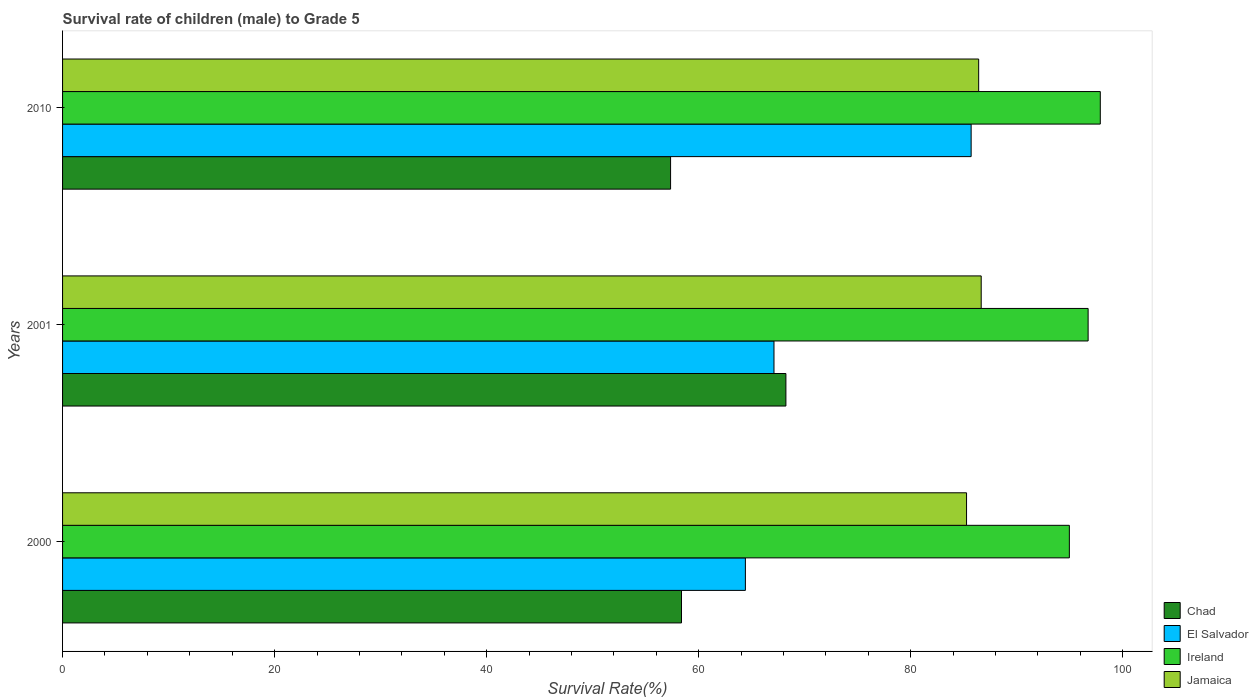How many different coloured bars are there?
Your answer should be compact. 4. How many groups of bars are there?
Offer a terse response. 3. What is the survival rate of male children to grade 5 in El Salvador in 2000?
Keep it short and to the point. 64.4. Across all years, what is the maximum survival rate of male children to grade 5 in Chad?
Your answer should be very brief. 68.22. Across all years, what is the minimum survival rate of male children to grade 5 in Chad?
Offer a very short reply. 57.35. In which year was the survival rate of male children to grade 5 in Chad minimum?
Ensure brevity in your answer.  2010. What is the total survival rate of male children to grade 5 in Jamaica in the graph?
Your response must be concise. 258.31. What is the difference between the survival rate of male children to grade 5 in Jamaica in 2001 and that in 2010?
Make the answer very short. 0.24. What is the difference between the survival rate of male children to grade 5 in Chad in 2000 and the survival rate of male children to grade 5 in Jamaica in 2001?
Offer a very short reply. -28.27. What is the average survival rate of male children to grade 5 in Jamaica per year?
Your answer should be compact. 86.1. In the year 2001, what is the difference between the survival rate of male children to grade 5 in Ireland and survival rate of male children to grade 5 in Jamaica?
Give a very brief answer. 10.08. In how many years, is the survival rate of male children to grade 5 in Ireland greater than 24 %?
Your answer should be compact. 3. What is the ratio of the survival rate of male children to grade 5 in El Salvador in 2000 to that in 2001?
Offer a very short reply. 0.96. What is the difference between the highest and the second highest survival rate of male children to grade 5 in Chad?
Give a very brief answer. 9.85. What is the difference between the highest and the lowest survival rate of male children to grade 5 in Chad?
Your answer should be very brief. 10.88. In how many years, is the survival rate of male children to grade 5 in El Salvador greater than the average survival rate of male children to grade 5 in El Salvador taken over all years?
Your answer should be compact. 1. Is it the case that in every year, the sum of the survival rate of male children to grade 5 in El Salvador and survival rate of male children to grade 5 in Ireland is greater than the sum of survival rate of male children to grade 5 in Jamaica and survival rate of male children to grade 5 in Chad?
Give a very brief answer. No. What does the 3rd bar from the top in 2010 represents?
Make the answer very short. El Salvador. What does the 1st bar from the bottom in 2010 represents?
Your answer should be very brief. Chad. Are all the bars in the graph horizontal?
Keep it short and to the point. Yes. What is the difference between two consecutive major ticks on the X-axis?
Give a very brief answer. 20. Are the values on the major ticks of X-axis written in scientific E-notation?
Your answer should be very brief. No. Does the graph contain any zero values?
Give a very brief answer. No. Does the graph contain grids?
Keep it short and to the point. No. Where does the legend appear in the graph?
Keep it short and to the point. Bottom right. How many legend labels are there?
Give a very brief answer. 4. What is the title of the graph?
Offer a terse response. Survival rate of children (male) to Grade 5. What is the label or title of the X-axis?
Make the answer very short. Survival Rate(%). What is the Survival Rate(%) in Chad in 2000?
Your response must be concise. 58.38. What is the Survival Rate(%) in El Salvador in 2000?
Provide a succinct answer. 64.4. What is the Survival Rate(%) of Ireland in 2000?
Keep it short and to the point. 94.96. What is the Survival Rate(%) in Jamaica in 2000?
Your answer should be compact. 85.26. What is the Survival Rate(%) of Chad in 2001?
Make the answer very short. 68.22. What is the Survival Rate(%) in El Salvador in 2001?
Provide a succinct answer. 67.1. What is the Survival Rate(%) in Ireland in 2001?
Provide a short and direct response. 96.73. What is the Survival Rate(%) of Jamaica in 2001?
Give a very brief answer. 86.64. What is the Survival Rate(%) in Chad in 2010?
Keep it short and to the point. 57.35. What is the Survival Rate(%) of El Salvador in 2010?
Your response must be concise. 85.7. What is the Survival Rate(%) of Ireland in 2010?
Your answer should be compact. 97.88. What is the Survival Rate(%) of Jamaica in 2010?
Give a very brief answer. 86.41. Across all years, what is the maximum Survival Rate(%) in Chad?
Ensure brevity in your answer.  68.22. Across all years, what is the maximum Survival Rate(%) of El Salvador?
Ensure brevity in your answer.  85.7. Across all years, what is the maximum Survival Rate(%) of Ireland?
Your answer should be very brief. 97.88. Across all years, what is the maximum Survival Rate(%) in Jamaica?
Provide a short and direct response. 86.64. Across all years, what is the minimum Survival Rate(%) of Chad?
Give a very brief answer. 57.35. Across all years, what is the minimum Survival Rate(%) of El Salvador?
Keep it short and to the point. 64.4. Across all years, what is the minimum Survival Rate(%) of Ireland?
Keep it short and to the point. 94.96. Across all years, what is the minimum Survival Rate(%) in Jamaica?
Offer a very short reply. 85.26. What is the total Survival Rate(%) of Chad in the graph?
Ensure brevity in your answer.  183.95. What is the total Survival Rate(%) in El Salvador in the graph?
Ensure brevity in your answer.  217.2. What is the total Survival Rate(%) in Ireland in the graph?
Your answer should be very brief. 289.56. What is the total Survival Rate(%) of Jamaica in the graph?
Offer a terse response. 258.31. What is the difference between the Survival Rate(%) of Chad in 2000 and that in 2001?
Give a very brief answer. -9.85. What is the difference between the Survival Rate(%) in El Salvador in 2000 and that in 2001?
Provide a succinct answer. -2.7. What is the difference between the Survival Rate(%) in Ireland in 2000 and that in 2001?
Provide a succinct answer. -1.77. What is the difference between the Survival Rate(%) in Jamaica in 2000 and that in 2001?
Your response must be concise. -1.38. What is the difference between the Survival Rate(%) in Chad in 2000 and that in 2010?
Your answer should be compact. 1.03. What is the difference between the Survival Rate(%) of El Salvador in 2000 and that in 2010?
Provide a succinct answer. -21.29. What is the difference between the Survival Rate(%) in Ireland in 2000 and that in 2010?
Make the answer very short. -2.92. What is the difference between the Survival Rate(%) in Jamaica in 2000 and that in 2010?
Your answer should be very brief. -1.14. What is the difference between the Survival Rate(%) in Chad in 2001 and that in 2010?
Offer a very short reply. 10.88. What is the difference between the Survival Rate(%) in El Salvador in 2001 and that in 2010?
Your response must be concise. -18.6. What is the difference between the Survival Rate(%) of Ireland in 2001 and that in 2010?
Your response must be concise. -1.15. What is the difference between the Survival Rate(%) of Jamaica in 2001 and that in 2010?
Make the answer very short. 0.24. What is the difference between the Survival Rate(%) of Chad in 2000 and the Survival Rate(%) of El Salvador in 2001?
Ensure brevity in your answer.  -8.72. What is the difference between the Survival Rate(%) of Chad in 2000 and the Survival Rate(%) of Ireland in 2001?
Give a very brief answer. -38.35. What is the difference between the Survival Rate(%) in Chad in 2000 and the Survival Rate(%) in Jamaica in 2001?
Provide a succinct answer. -28.27. What is the difference between the Survival Rate(%) in El Salvador in 2000 and the Survival Rate(%) in Ireland in 2001?
Offer a terse response. -32.33. What is the difference between the Survival Rate(%) in El Salvador in 2000 and the Survival Rate(%) in Jamaica in 2001?
Ensure brevity in your answer.  -22.24. What is the difference between the Survival Rate(%) of Ireland in 2000 and the Survival Rate(%) of Jamaica in 2001?
Provide a short and direct response. 8.31. What is the difference between the Survival Rate(%) of Chad in 2000 and the Survival Rate(%) of El Salvador in 2010?
Offer a terse response. -27.32. What is the difference between the Survival Rate(%) in Chad in 2000 and the Survival Rate(%) in Ireland in 2010?
Offer a terse response. -39.5. What is the difference between the Survival Rate(%) in Chad in 2000 and the Survival Rate(%) in Jamaica in 2010?
Your answer should be very brief. -28.03. What is the difference between the Survival Rate(%) in El Salvador in 2000 and the Survival Rate(%) in Ireland in 2010?
Offer a terse response. -33.47. What is the difference between the Survival Rate(%) in El Salvador in 2000 and the Survival Rate(%) in Jamaica in 2010?
Make the answer very short. -22. What is the difference between the Survival Rate(%) in Ireland in 2000 and the Survival Rate(%) in Jamaica in 2010?
Give a very brief answer. 8.55. What is the difference between the Survival Rate(%) in Chad in 2001 and the Survival Rate(%) in El Salvador in 2010?
Offer a very short reply. -17.47. What is the difference between the Survival Rate(%) of Chad in 2001 and the Survival Rate(%) of Ireland in 2010?
Your answer should be compact. -29.65. What is the difference between the Survival Rate(%) in Chad in 2001 and the Survival Rate(%) in Jamaica in 2010?
Ensure brevity in your answer.  -18.18. What is the difference between the Survival Rate(%) in El Salvador in 2001 and the Survival Rate(%) in Ireland in 2010?
Your response must be concise. -30.78. What is the difference between the Survival Rate(%) of El Salvador in 2001 and the Survival Rate(%) of Jamaica in 2010?
Your response must be concise. -19.31. What is the difference between the Survival Rate(%) in Ireland in 2001 and the Survival Rate(%) in Jamaica in 2010?
Your answer should be compact. 10.32. What is the average Survival Rate(%) of Chad per year?
Give a very brief answer. 61.32. What is the average Survival Rate(%) of El Salvador per year?
Offer a very short reply. 72.4. What is the average Survival Rate(%) of Ireland per year?
Your response must be concise. 96.52. What is the average Survival Rate(%) of Jamaica per year?
Your answer should be compact. 86.1. In the year 2000, what is the difference between the Survival Rate(%) of Chad and Survival Rate(%) of El Salvador?
Your response must be concise. -6.03. In the year 2000, what is the difference between the Survival Rate(%) of Chad and Survival Rate(%) of Ireland?
Give a very brief answer. -36.58. In the year 2000, what is the difference between the Survival Rate(%) of Chad and Survival Rate(%) of Jamaica?
Your answer should be very brief. -26.88. In the year 2000, what is the difference between the Survival Rate(%) of El Salvador and Survival Rate(%) of Ireland?
Offer a very short reply. -30.56. In the year 2000, what is the difference between the Survival Rate(%) in El Salvador and Survival Rate(%) in Jamaica?
Provide a short and direct response. -20.86. In the year 2000, what is the difference between the Survival Rate(%) in Ireland and Survival Rate(%) in Jamaica?
Give a very brief answer. 9.7. In the year 2001, what is the difference between the Survival Rate(%) in Chad and Survival Rate(%) in El Salvador?
Give a very brief answer. 1.12. In the year 2001, what is the difference between the Survival Rate(%) of Chad and Survival Rate(%) of Ireland?
Offer a terse response. -28.5. In the year 2001, what is the difference between the Survival Rate(%) in Chad and Survival Rate(%) in Jamaica?
Provide a succinct answer. -18.42. In the year 2001, what is the difference between the Survival Rate(%) of El Salvador and Survival Rate(%) of Ireland?
Provide a short and direct response. -29.63. In the year 2001, what is the difference between the Survival Rate(%) of El Salvador and Survival Rate(%) of Jamaica?
Provide a succinct answer. -19.55. In the year 2001, what is the difference between the Survival Rate(%) of Ireland and Survival Rate(%) of Jamaica?
Your answer should be compact. 10.08. In the year 2010, what is the difference between the Survival Rate(%) in Chad and Survival Rate(%) in El Salvador?
Give a very brief answer. -28.35. In the year 2010, what is the difference between the Survival Rate(%) of Chad and Survival Rate(%) of Ireland?
Offer a very short reply. -40.53. In the year 2010, what is the difference between the Survival Rate(%) of Chad and Survival Rate(%) of Jamaica?
Provide a short and direct response. -29.06. In the year 2010, what is the difference between the Survival Rate(%) of El Salvador and Survival Rate(%) of Ireland?
Your answer should be very brief. -12.18. In the year 2010, what is the difference between the Survival Rate(%) in El Salvador and Survival Rate(%) in Jamaica?
Give a very brief answer. -0.71. In the year 2010, what is the difference between the Survival Rate(%) in Ireland and Survival Rate(%) in Jamaica?
Keep it short and to the point. 11.47. What is the ratio of the Survival Rate(%) of Chad in 2000 to that in 2001?
Provide a succinct answer. 0.86. What is the ratio of the Survival Rate(%) in El Salvador in 2000 to that in 2001?
Ensure brevity in your answer.  0.96. What is the ratio of the Survival Rate(%) of Ireland in 2000 to that in 2001?
Your answer should be very brief. 0.98. What is the ratio of the Survival Rate(%) of Chad in 2000 to that in 2010?
Keep it short and to the point. 1.02. What is the ratio of the Survival Rate(%) of El Salvador in 2000 to that in 2010?
Offer a terse response. 0.75. What is the ratio of the Survival Rate(%) in Ireland in 2000 to that in 2010?
Make the answer very short. 0.97. What is the ratio of the Survival Rate(%) in Chad in 2001 to that in 2010?
Give a very brief answer. 1.19. What is the ratio of the Survival Rate(%) in El Salvador in 2001 to that in 2010?
Keep it short and to the point. 0.78. What is the ratio of the Survival Rate(%) of Ireland in 2001 to that in 2010?
Your answer should be compact. 0.99. What is the ratio of the Survival Rate(%) in Jamaica in 2001 to that in 2010?
Provide a succinct answer. 1. What is the difference between the highest and the second highest Survival Rate(%) in Chad?
Your answer should be very brief. 9.85. What is the difference between the highest and the second highest Survival Rate(%) in El Salvador?
Provide a short and direct response. 18.6. What is the difference between the highest and the second highest Survival Rate(%) in Ireland?
Provide a short and direct response. 1.15. What is the difference between the highest and the second highest Survival Rate(%) in Jamaica?
Provide a succinct answer. 0.24. What is the difference between the highest and the lowest Survival Rate(%) in Chad?
Your answer should be very brief. 10.88. What is the difference between the highest and the lowest Survival Rate(%) of El Salvador?
Provide a short and direct response. 21.29. What is the difference between the highest and the lowest Survival Rate(%) of Ireland?
Your response must be concise. 2.92. What is the difference between the highest and the lowest Survival Rate(%) of Jamaica?
Offer a very short reply. 1.38. 